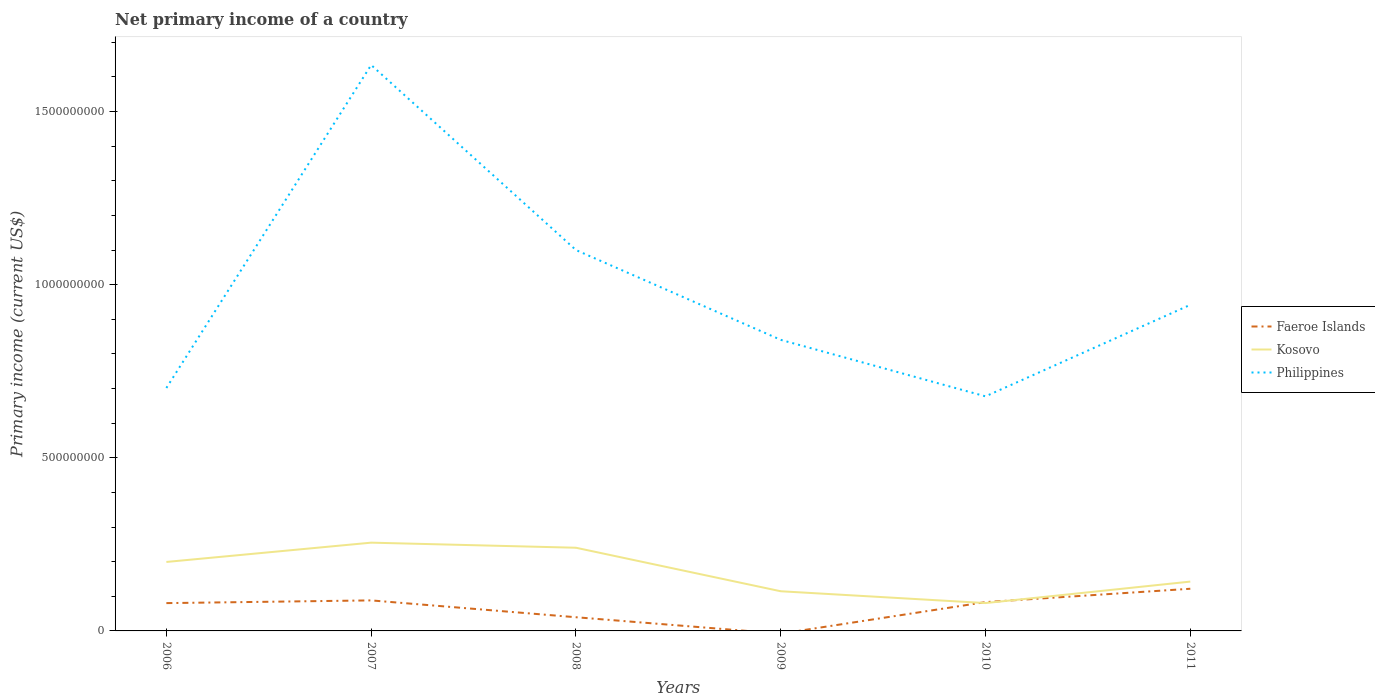Does the line corresponding to Kosovo intersect with the line corresponding to Faeroe Islands?
Your answer should be compact. Yes. Across all years, what is the maximum primary income in Philippines?
Offer a terse response. 6.77e+08. What is the total primary income in Kosovo in the graph?
Your answer should be very brief. 1.12e+08. What is the difference between the highest and the second highest primary income in Faeroe Islands?
Offer a terse response. 1.22e+08. How many lines are there?
Offer a terse response. 3. How many years are there in the graph?
Your answer should be very brief. 6. What is the difference between two consecutive major ticks on the Y-axis?
Make the answer very short. 5.00e+08. Are the values on the major ticks of Y-axis written in scientific E-notation?
Provide a short and direct response. No. Does the graph contain grids?
Provide a short and direct response. No. Where does the legend appear in the graph?
Keep it short and to the point. Center right. What is the title of the graph?
Keep it short and to the point. Net primary income of a country. What is the label or title of the X-axis?
Ensure brevity in your answer.  Years. What is the label or title of the Y-axis?
Keep it short and to the point. Primary income (current US$). What is the Primary income (current US$) of Faeroe Islands in 2006?
Give a very brief answer. 8.03e+07. What is the Primary income (current US$) in Kosovo in 2006?
Give a very brief answer. 1.99e+08. What is the Primary income (current US$) in Philippines in 2006?
Ensure brevity in your answer.  7.02e+08. What is the Primary income (current US$) in Faeroe Islands in 2007?
Provide a short and direct response. 8.82e+07. What is the Primary income (current US$) in Kosovo in 2007?
Your answer should be very brief. 2.55e+08. What is the Primary income (current US$) in Philippines in 2007?
Your response must be concise. 1.63e+09. What is the Primary income (current US$) in Faeroe Islands in 2008?
Your response must be concise. 3.95e+07. What is the Primary income (current US$) of Kosovo in 2008?
Keep it short and to the point. 2.40e+08. What is the Primary income (current US$) of Philippines in 2008?
Keep it short and to the point. 1.10e+09. What is the Primary income (current US$) of Kosovo in 2009?
Ensure brevity in your answer.  1.15e+08. What is the Primary income (current US$) of Philippines in 2009?
Offer a terse response. 8.41e+08. What is the Primary income (current US$) in Faeroe Islands in 2010?
Your response must be concise. 8.32e+07. What is the Primary income (current US$) of Kosovo in 2010?
Ensure brevity in your answer.  8.05e+07. What is the Primary income (current US$) of Philippines in 2010?
Offer a very short reply. 6.77e+08. What is the Primary income (current US$) of Faeroe Islands in 2011?
Provide a short and direct response. 1.22e+08. What is the Primary income (current US$) of Kosovo in 2011?
Your answer should be very brief. 1.42e+08. What is the Primary income (current US$) of Philippines in 2011?
Ensure brevity in your answer.  9.42e+08. Across all years, what is the maximum Primary income (current US$) in Faeroe Islands?
Make the answer very short. 1.22e+08. Across all years, what is the maximum Primary income (current US$) in Kosovo?
Offer a terse response. 2.55e+08. Across all years, what is the maximum Primary income (current US$) in Philippines?
Ensure brevity in your answer.  1.63e+09. Across all years, what is the minimum Primary income (current US$) of Faeroe Islands?
Provide a short and direct response. 0. Across all years, what is the minimum Primary income (current US$) of Kosovo?
Provide a succinct answer. 8.05e+07. Across all years, what is the minimum Primary income (current US$) in Philippines?
Offer a terse response. 6.77e+08. What is the total Primary income (current US$) in Faeroe Islands in the graph?
Give a very brief answer. 4.13e+08. What is the total Primary income (current US$) in Kosovo in the graph?
Offer a very short reply. 1.03e+09. What is the total Primary income (current US$) in Philippines in the graph?
Provide a succinct answer. 5.90e+09. What is the difference between the Primary income (current US$) of Faeroe Islands in 2006 and that in 2007?
Your answer should be very brief. -7.85e+06. What is the difference between the Primary income (current US$) in Kosovo in 2006 and that in 2007?
Your response must be concise. -5.57e+07. What is the difference between the Primary income (current US$) in Philippines in 2006 and that in 2007?
Your response must be concise. -9.33e+08. What is the difference between the Primary income (current US$) of Faeroe Islands in 2006 and that in 2008?
Offer a terse response. 4.08e+07. What is the difference between the Primary income (current US$) in Kosovo in 2006 and that in 2008?
Provide a short and direct response. -4.10e+07. What is the difference between the Primary income (current US$) in Philippines in 2006 and that in 2008?
Ensure brevity in your answer.  -3.98e+08. What is the difference between the Primary income (current US$) in Kosovo in 2006 and that in 2009?
Provide a succinct answer. 8.46e+07. What is the difference between the Primary income (current US$) of Philippines in 2006 and that in 2009?
Provide a short and direct response. -1.39e+08. What is the difference between the Primary income (current US$) in Faeroe Islands in 2006 and that in 2010?
Provide a succinct answer. -2.93e+06. What is the difference between the Primary income (current US$) in Kosovo in 2006 and that in 2010?
Offer a terse response. 1.19e+08. What is the difference between the Primary income (current US$) in Philippines in 2006 and that in 2010?
Provide a short and direct response. 2.42e+07. What is the difference between the Primary income (current US$) of Faeroe Islands in 2006 and that in 2011?
Keep it short and to the point. -4.15e+07. What is the difference between the Primary income (current US$) in Kosovo in 2006 and that in 2011?
Offer a very short reply. 5.67e+07. What is the difference between the Primary income (current US$) of Philippines in 2006 and that in 2011?
Keep it short and to the point. -2.40e+08. What is the difference between the Primary income (current US$) in Faeroe Islands in 2007 and that in 2008?
Provide a succinct answer. 4.86e+07. What is the difference between the Primary income (current US$) of Kosovo in 2007 and that in 2008?
Offer a very short reply. 1.47e+07. What is the difference between the Primary income (current US$) in Philippines in 2007 and that in 2008?
Provide a short and direct response. 5.34e+08. What is the difference between the Primary income (current US$) in Kosovo in 2007 and that in 2009?
Give a very brief answer. 1.40e+08. What is the difference between the Primary income (current US$) of Philippines in 2007 and that in 2009?
Your answer should be compact. 7.94e+08. What is the difference between the Primary income (current US$) in Faeroe Islands in 2007 and that in 2010?
Provide a short and direct response. 4.93e+06. What is the difference between the Primary income (current US$) in Kosovo in 2007 and that in 2010?
Ensure brevity in your answer.  1.74e+08. What is the difference between the Primary income (current US$) of Philippines in 2007 and that in 2010?
Ensure brevity in your answer.  9.57e+08. What is the difference between the Primary income (current US$) of Faeroe Islands in 2007 and that in 2011?
Provide a short and direct response. -3.36e+07. What is the difference between the Primary income (current US$) of Kosovo in 2007 and that in 2011?
Ensure brevity in your answer.  1.12e+08. What is the difference between the Primary income (current US$) of Philippines in 2007 and that in 2011?
Offer a terse response. 6.93e+08. What is the difference between the Primary income (current US$) in Kosovo in 2008 and that in 2009?
Your answer should be very brief. 1.26e+08. What is the difference between the Primary income (current US$) of Philippines in 2008 and that in 2009?
Offer a terse response. 2.59e+08. What is the difference between the Primary income (current US$) in Faeroe Islands in 2008 and that in 2010?
Your answer should be compact. -4.37e+07. What is the difference between the Primary income (current US$) in Kosovo in 2008 and that in 2010?
Offer a very short reply. 1.60e+08. What is the difference between the Primary income (current US$) in Philippines in 2008 and that in 2010?
Make the answer very short. 4.23e+08. What is the difference between the Primary income (current US$) of Faeroe Islands in 2008 and that in 2011?
Your answer should be compact. -8.22e+07. What is the difference between the Primary income (current US$) of Kosovo in 2008 and that in 2011?
Give a very brief answer. 9.78e+07. What is the difference between the Primary income (current US$) of Philippines in 2008 and that in 2011?
Give a very brief answer. 1.58e+08. What is the difference between the Primary income (current US$) of Kosovo in 2009 and that in 2010?
Your answer should be compact. 3.41e+07. What is the difference between the Primary income (current US$) in Philippines in 2009 and that in 2010?
Make the answer very short. 1.63e+08. What is the difference between the Primary income (current US$) of Kosovo in 2009 and that in 2011?
Your answer should be very brief. -2.79e+07. What is the difference between the Primary income (current US$) in Philippines in 2009 and that in 2011?
Keep it short and to the point. -1.01e+08. What is the difference between the Primary income (current US$) of Faeroe Islands in 2010 and that in 2011?
Provide a succinct answer. -3.85e+07. What is the difference between the Primary income (current US$) of Kosovo in 2010 and that in 2011?
Provide a short and direct response. -6.20e+07. What is the difference between the Primary income (current US$) in Philippines in 2010 and that in 2011?
Provide a short and direct response. -2.64e+08. What is the difference between the Primary income (current US$) of Faeroe Islands in 2006 and the Primary income (current US$) of Kosovo in 2007?
Ensure brevity in your answer.  -1.75e+08. What is the difference between the Primary income (current US$) of Faeroe Islands in 2006 and the Primary income (current US$) of Philippines in 2007?
Offer a terse response. -1.55e+09. What is the difference between the Primary income (current US$) in Kosovo in 2006 and the Primary income (current US$) in Philippines in 2007?
Provide a short and direct response. -1.44e+09. What is the difference between the Primary income (current US$) in Faeroe Islands in 2006 and the Primary income (current US$) in Kosovo in 2008?
Ensure brevity in your answer.  -1.60e+08. What is the difference between the Primary income (current US$) of Faeroe Islands in 2006 and the Primary income (current US$) of Philippines in 2008?
Offer a very short reply. -1.02e+09. What is the difference between the Primary income (current US$) in Kosovo in 2006 and the Primary income (current US$) in Philippines in 2008?
Make the answer very short. -9.01e+08. What is the difference between the Primary income (current US$) in Faeroe Islands in 2006 and the Primary income (current US$) in Kosovo in 2009?
Provide a short and direct response. -3.43e+07. What is the difference between the Primary income (current US$) of Faeroe Islands in 2006 and the Primary income (current US$) of Philippines in 2009?
Keep it short and to the point. -7.60e+08. What is the difference between the Primary income (current US$) of Kosovo in 2006 and the Primary income (current US$) of Philippines in 2009?
Make the answer very short. -6.41e+08. What is the difference between the Primary income (current US$) in Faeroe Islands in 2006 and the Primary income (current US$) in Kosovo in 2010?
Your answer should be very brief. -1.41e+05. What is the difference between the Primary income (current US$) in Faeroe Islands in 2006 and the Primary income (current US$) in Philippines in 2010?
Give a very brief answer. -5.97e+08. What is the difference between the Primary income (current US$) of Kosovo in 2006 and the Primary income (current US$) of Philippines in 2010?
Offer a terse response. -4.78e+08. What is the difference between the Primary income (current US$) of Faeroe Islands in 2006 and the Primary income (current US$) of Kosovo in 2011?
Keep it short and to the point. -6.21e+07. What is the difference between the Primary income (current US$) in Faeroe Islands in 2006 and the Primary income (current US$) in Philippines in 2011?
Your response must be concise. -8.61e+08. What is the difference between the Primary income (current US$) of Kosovo in 2006 and the Primary income (current US$) of Philippines in 2011?
Ensure brevity in your answer.  -7.43e+08. What is the difference between the Primary income (current US$) in Faeroe Islands in 2007 and the Primary income (current US$) in Kosovo in 2008?
Give a very brief answer. -1.52e+08. What is the difference between the Primary income (current US$) of Faeroe Islands in 2007 and the Primary income (current US$) of Philippines in 2008?
Your answer should be compact. -1.01e+09. What is the difference between the Primary income (current US$) of Kosovo in 2007 and the Primary income (current US$) of Philippines in 2008?
Provide a short and direct response. -8.45e+08. What is the difference between the Primary income (current US$) of Faeroe Islands in 2007 and the Primary income (current US$) of Kosovo in 2009?
Your answer should be compact. -2.64e+07. What is the difference between the Primary income (current US$) of Faeroe Islands in 2007 and the Primary income (current US$) of Philippines in 2009?
Offer a very short reply. -7.53e+08. What is the difference between the Primary income (current US$) in Kosovo in 2007 and the Primary income (current US$) in Philippines in 2009?
Offer a terse response. -5.86e+08. What is the difference between the Primary income (current US$) in Faeroe Islands in 2007 and the Primary income (current US$) in Kosovo in 2010?
Give a very brief answer. 7.71e+06. What is the difference between the Primary income (current US$) of Faeroe Islands in 2007 and the Primary income (current US$) of Philippines in 2010?
Ensure brevity in your answer.  -5.89e+08. What is the difference between the Primary income (current US$) in Kosovo in 2007 and the Primary income (current US$) in Philippines in 2010?
Give a very brief answer. -4.23e+08. What is the difference between the Primary income (current US$) in Faeroe Islands in 2007 and the Primary income (current US$) in Kosovo in 2011?
Give a very brief answer. -5.43e+07. What is the difference between the Primary income (current US$) in Faeroe Islands in 2007 and the Primary income (current US$) in Philippines in 2011?
Give a very brief answer. -8.54e+08. What is the difference between the Primary income (current US$) in Kosovo in 2007 and the Primary income (current US$) in Philippines in 2011?
Offer a very short reply. -6.87e+08. What is the difference between the Primary income (current US$) of Faeroe Islands in 2008 and the Primary income (current US$) of Kosovo in 2009?
Your answer should be compact. -7.50e+07. What is the difference between the Primary income (current US$) in Faeroe Islands in 2008 and the Primary income (current US$) in Philippines in 2009?
Your answer should be compact. -8.01e+08. What is the difference between the Primary income (current US$) of Kosovo in 2008 and the Primary income (current US$) of Philippines in 2009?
Provide a short and direct response. -6.00e+08. What is the difference between the Primary income (current US$) of Faeroe Islands in 2008 and the Primary income (current US$) of Kosovo in 2010?
Keep it short and to the point. -4.09e+07. What is the difference between the Primary income (current US$) of Faeroe Islands in 2008 and the Primary income (current US$) of Philippines in 2010?
Ensure brevity in your answer.  -6.38e+08. What is the difference between the Primary income (current US$) of Kosovo in 2008 and the Primary income (current US$) of Philippines in 2010?
Your answer should be compact. -4.37e+08. What is the difference between the Primary income (current US$) in Faeroe Islands in 2008 and the Primary income (current US$) in Kosovo in 2011?
Your answer should be compact. -1.03e+08. What is the difference between the Primary income (current US$) of Faeroe Islands in 2008 and the Primary income (current US$) of Philippines in 2011?
Keep it short and to the point. -9.02e+08. What is the difference between the Primary income (current US$) of Kosovo in 2008 and the Primary income (current US$) of Philippines in 2011?
Ensure brevity in your answer.  -7.02e+08. What is the difference between the Primary income (current US$) in Kosovo in 2009 and the Primary income (current US$) in Philippines in 2010?
Your answer should be very brief. -5.63e+08. What is the difference between the Primary income (current US$) of Kosovo in 2009 and the Primary income (current US$) of Philippines in 2011?
Provide a short and direct response. -8.27e+08. What is the difference between the Primary income (current US$) in Faeroe Islands in 2010 and the Primary income (current US$) in Kosovo in 2011?
Provide a succinct answer. -5.92e+07. What is the difference between the Primary income (current US$) in Faeroe Islands in 2010 and the Primary income (current US$) in Philippines in 2011?
Keep it short and to the point. -8.59e+08. What is the difference between the Primary income (current US$) of Kosovo in 2010 and the Primary income (current US$) of Philippines in 2011?
Offer a terse response. -8.61e+08. What is the average Primary income (current US$) in Faeroe Islands per year?
Offer a very short reply. 6.88e+07. What is the average Primary income (current US$) in Kosovo per year?
Offer a terse response. 1.72e+08. What is the average Primary income (current US$) of Philippines per year?
Give a very brief answer. 9.83e+08. In the year 2006, what is the difference between the Primary income (current US$) in Faeroe Islands and Primary income (current US$) in Kosovo?
Offer a terse response. -1.19e+08. In the year 2006, what is the difference between the Primary income (current US$) in Faeroe Islands and Primary income (current US$) in Philippines?
Your answer should be very brief. -6.21e+08. In the year 2006, what is the difference between the Primary income (current US$) in Kosovo and Primary income (current US$) in Philippines?
Give a very brief answer. -5.02e+08. In the year 2007, what is the difference between the Primary income (current US$) of Faeroe Islands and Primary income (current US$) of Kosovo?
Your response must be concise. -1.67e+08. In the year 2007, what is the difference between the Primary income (current US$) in Faeroe Islands and Primary income (current US$) in Philippines?
Offer a terse response. -1.55e+09. In the year 2007, what is the difference between the Primary income (current US$) of Kosovo and Primary income (current US$) of Philippines?
Provide a short and direct response. -1.38e+09. In the year 2008, what is the difference between the Primary income (current US$) in Faeroe Islands and Primary income (current US$) in Kosovo?
Keep it short and to the point. -2.01e+08. In the year 2008, what is the difference between the Primary income (current US$) in Faeroe Islands and Primary income (current US$) in Philippines?
Your answer should be very brief. -1.06e+09. In the year 2008, what is the difference between the Primary income (current US$) in Kosovo and Primary income (current US$) in Philippines?
Ensure brevity in your answer.  -8.60e+08. In the year 2009, what is the difference between the Primary income (current US$) of Kosovo and Primary income (current US$) of Philippines?
Offer a very short reply. -7.26e+08. In the year 2010, what is the difference between the Primary income (current US$) in Faeroe Islands and Primary income (current US$) in Kosovo?
Provide a succinct answer. 2.79e+06. In the year 2010, what is the difference between the Primary income (current US$) of Faeroe Islands and Primary income (current US$) of Philippines?
Your answer should be compact. -5.94e+08. In the year 2010, what is the difference between the Primary income (current US$) of Kosovo and Primary income (current US$) of Philippines?
Make the answer very short. -5.97e+08. In the year 2011, what is the difference between the Primary income (current US$) of Faeroe Islands and Primary income (current US$) of Kosovo?
Your response must be concise. -2.07e+07. In the year 2011, what is the difference between the Primary income (current US$) of Faeroe Islands and Primary income (current US$) of Philippines?
Your answer should be compact. -8.20e+08. In the year 2011, what is the difference between the Primary income (current US$) in Kosovo and Primary income (current US$) in Philippines?
Provide a short and direct response. -7.99e+08. What is the ratio of the Primary income (current US$) of Faeroe Islands in 2006 to that in 2007?
Keep it short and to the point. 0.91. What is the ratio of the Primary income (current US$) in Kosovo in 2006 to that in 2007?
Your response must be concise. 0.78. What is the ratio of the Primary income (current US$) in Philippines in 2006 to that in 2007?
Ensure brevity in your answer.  0.43. What is the ratio of the Primary income (current US$) of Faeroe Islands in 2006 to that in 2008?
Your answer should be compact. 2.03. What is the ratio of the Primary income (current US$) in Kosovo in 2006 to that in 2008?
Give a very brief answer. 0.83. What is the ratio of the Primary income (current US$) of Philippines in 2006 to that in 2008?
Offer a very short reply. 0.64. What is the ratio of the Primary income (current US$) of Kosovo in 2006 to that in 2009?
Your answer should be very brief. 1.74. What is the ratio of the Primary income (current US$) in Philippines in 2006 to that in 2009?
Keep it short and to the point. 0.83. What is the ratio of the Primary income (current US$) in Faeroe Islands in 2006 to that in 2010?
Ensure brevity in your answer.  0.96. What is the ratio of the Primary income (current US$) in Kosovo in 2006 to that in 2010?
Provide a short and direct response. 2.48. What is the ratio of the Primary income (current US$) of Philippines in 2006 to that in 2010?
Ensure brevity in your answer.  1.04. What is the ratio of the Primary income (current US$) in Faeroe Islands in 2006 to that in 2011?
Offer a terse response. 0.66. What is the ratio of the Primary income (current US$) in Kosovo in 2006 to that in 2011?
Provide a succinct answer. 1.4. What is the ratio of the Primary income (current US$) in Philippines in 2006 to that in 2011?
Keep it short and to the point. 0.74. What is the ratio of the Primary income (current US$) of Faeroe Islands in 2007 to that in 2008?
Give a very brief answer. 2.23. What is the ratio of the Primary income (current US$) in Kosovo in 2007 to that in 2008?
Make the answer very short. 1.06. What is the ratio of the Primary income (current US$) in Philippines in 2007 to that in 2008?
Provide a succinct answer. 1.49. What is the ratio of the Primary income (current US$) in Kosovo in 2007 to that in 2009?
Offer a terse response. 2.23. What is the ratio of the Primary income (current US$) in Philippines in 2007 to that in 2009?
Give a very brief answer. 1.94. What is the ratio of the Primary income (current US$) of Faeroe Islands in 2007 to that in 2010?
Your answer should be very brief. 1.06. What is the ratio of the Primary income (current US$) in Kosovo in 2007 to that in 2010?
Your answer should be very brief. 3.17. What is the ratio of the Primary income (current US$) of Philippines in 2007 to that in 2010?
Ensure brevity in your answer.  2.41. What is the ratio of the Primary income (current US$) of Faeroe Islands in 2007 to that in 2011?
Your answer should be compact. 0.72. What is the ratio of the Primary income (current US$) of Kosovo in 2007 to that in 2011?
Provide a succinct answer. 1.79. What is the ratio of the Primary income (current US$) of Philippines in 2007 to that in 2011?
Ensure brevity in your answer.  1.74. What is the ratio of the Primary income (current US$) of Kosovo in 2008 to that in 2009?
Provide a succinct answer. 2.1. What is the ratio of the Primary income (current US$) in Philippines in 2008 to that in 2009?
Provide a short and direct response. 1.31. What is the ratio of the Primary income (current US$) of Faeroe Islands in 2008 to that in 2010?
Give a very brief answer. 0.47. What is the ratio of the Primary income (current US$) of Kosovo in 2008 to that in 2010?
Offer a terse response. 2.99. What is the ratio of the Primary income (current US$) in Philippines in 2008 to that in 2010?
Provide a succinct answer. 1.62. What is the ratio of the Primary income (current US$) in Faeroe Islands in 2008 to that in 2011?
Provide a succinct answer. 0.32. What is the ratio of the Primary income (current US$) of Kosovo in 2008 to that in 2011?
Your answer should be compact. 1.69. What is the ratio of the Primary income (current US$) in Philippines in 2008 to that in 2011?
Ensure brevity in your answer.  1.17. What is the ratio of the Primary income (current US$) of Kosovo in 2009 to that in 2010?
Keep it short and to the point. 1.42. What is the ratio of the Primary income (current US$) in Philippines in 2009 to that in 2010?
Offer a very short reply. 1.24. What is the ratio of the Primary income (current US$) of Kosovo in 2009 to that in 2011?
Your response must be concise. 0.8. What is the ratio of the Primary income (current US$) of Philippines in 2009 to that in 2011?
Offer a very short reply. 0.89. What is the ratio of the Primary income (current US$) in Faeroe Islands in 2010 to that in 2011?
Your answer should be very brief. 0.68. What is the ratio of the Primary income (current US$) in Kosovo in 2010 to that in 2011?
Your response must be concise. 0.56. What is the ratio of the Primary income (current US$) of Philippines in 2010 to that in 2011?
Provide a succinct answer. 0.72. What is the difference between the highest and the second highest Primary income (current US$) of Faeroe Islands?
Provide a succinct answer. 3.36e+07. What is the difference between the highest and the second highest Primary income (current US$) in Kosovo?
Your response must be concise. 1.47e+07. What is the difference between the highest and the second highest Primary income (current US$) of Philippines?
Offer a terse response. 5.34e+08. What is the difference between the highest and the lowest Primary income (current US$) in Faeroe Islands?
Your response must be concise. 1.22e+08. What is the difference between the highest and the lowest Primary income (current US$) in Kosovo?
Your answer should be very brief. 1.74e+08. What is the difference between the highest and the lowest Primary income (current US$) of Philippines?
Offer a terse response. 9.57e+08. 